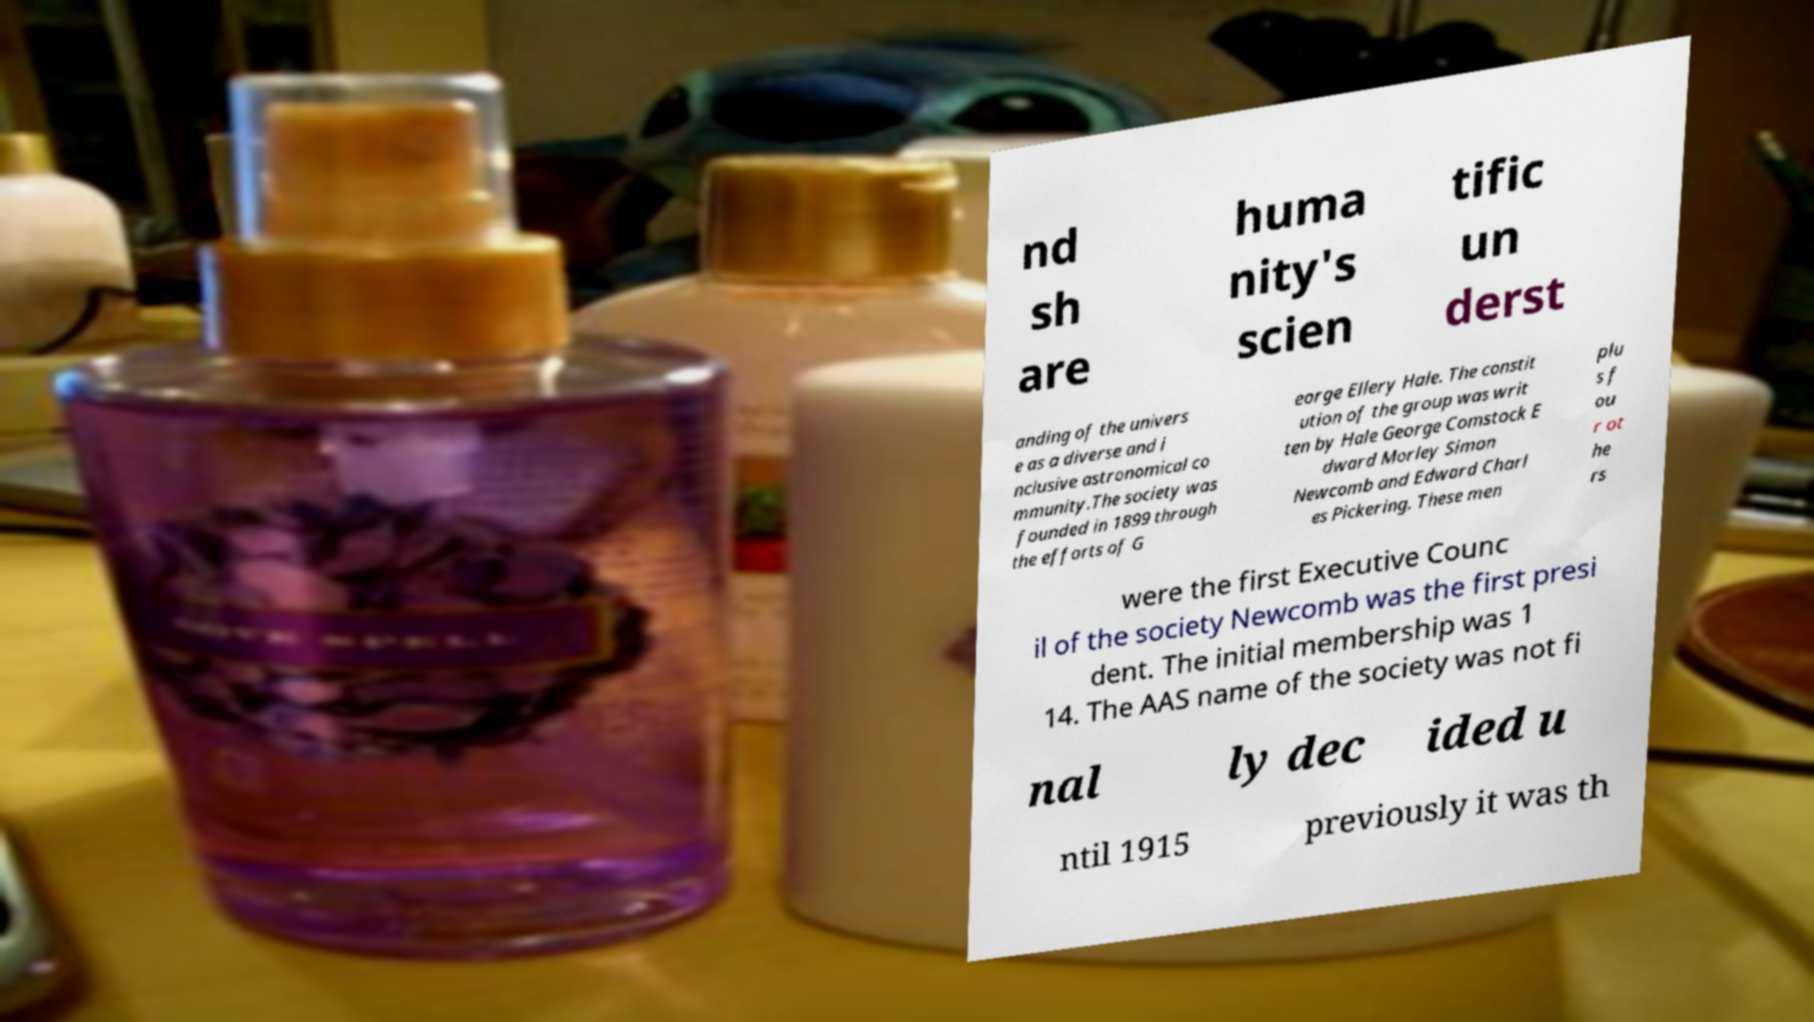Can you accurately transcribe the text from the provided image for me? nd sh are huma nity's scien tific un derst anding of the univers e as a diverse and i nclusive astronomical co mmunity.The society was founded in 1899 through the efforts of G eorge Ellery Hale. The constit ution of the group was writ ten by Hale George Comstock E dward Morley Simon Newcomb and Edward Charl es Pickering. These men plu s f ou r ot he rs were the first Executive Counc il of the society Newcomb was the first presi dent. The initial membership was 1 14. The AAS name of the society was not fi nal ly dec ided u ntil 1915 previously it was th 